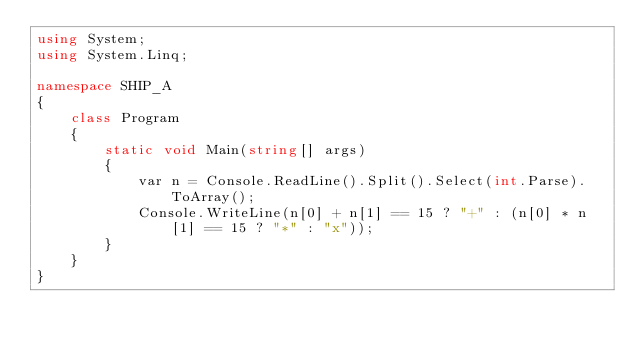<code> <loc_0><loc_0><loc_500><loc_500><_C#_>using System;
using System.Linq;

namespace SHIP_A
{
    class Program
    {
        static void Main(string[] args)
        {
            var n = Console.ReadLine().Split().Select(int.Parse).ToArray();
            Console.WriteLine(n[0] + n[1] == 15 ? "+" : (n[0] * n[1] == 15 ? "*" : "x"));
        }
    }
}
</code> 